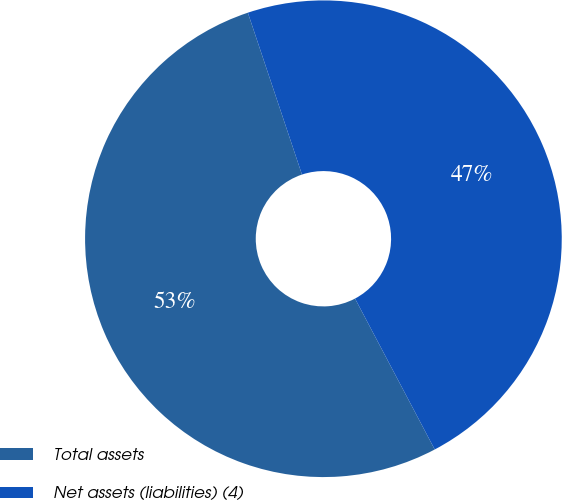<chart> <loc_0><loc_0><loc_500><loc_500><pie_chart><fcel>Total assets<fcel>Net assets (liabilities) (4)<nl><fcel>52.6%<fcel>47.4%<nl></chart> 